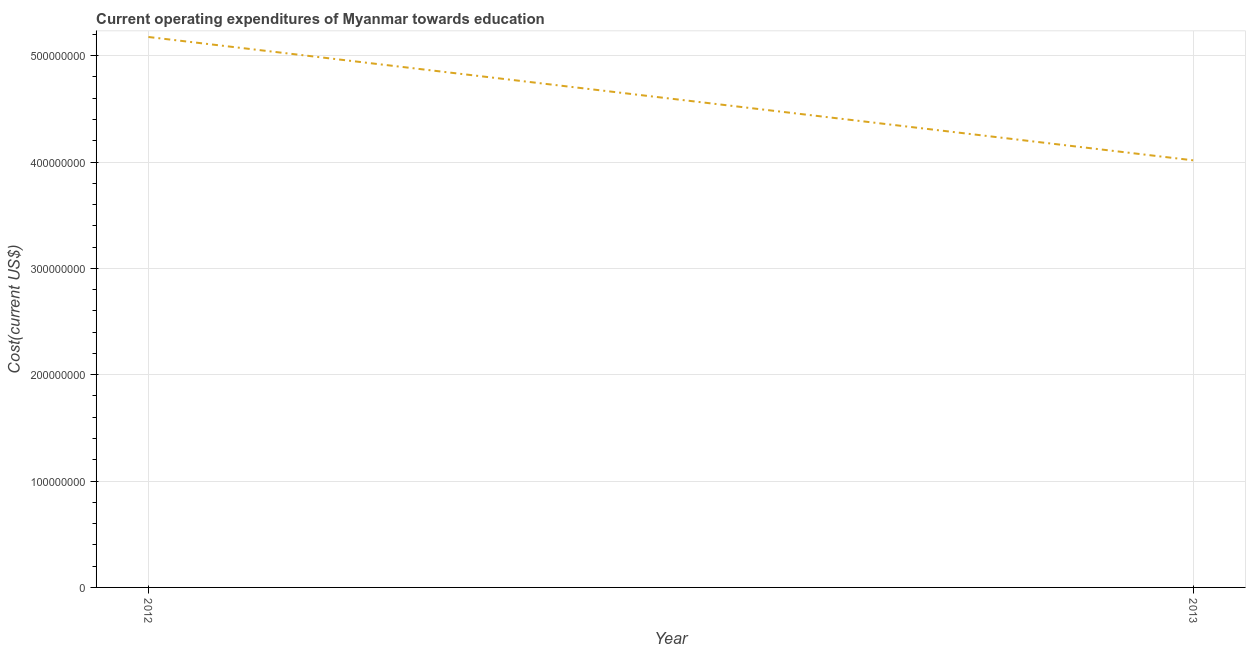What is the education expenditure in 2013?
Your response must be concise. 4.02e+08. Across all years, what is the maximum education expenditure?
Provide a succinct answer. 5.18e+08. Across all years, what is the minimum education expenditure?
Ensure brevity in your answer.  4.02e+08. What is the sum of the education expenditure?
Your answer should be very brief. 9.19e+08. What is the difference between the education expenditure in 2012 and 2013?
Make the answer very short. 1.16e+08. What is the average education expenditure per year?
Ensure brevity in your answer.  4.60e+08. What is the median education expenditure?
Your answer should be very brief. 4.60e+08. In how many years, is the education expenditure greater than 360000000 US$?
Ensure brevity in your answer.  2. What is the ratio of the education expenditure in 2012 to that in 2013?
Your answer should be compact. 1.29. In how many years, is the education expenditure greater than the average education expenditure taken over all years?
Ensure brevity in your answer.  1. How many years are there in the graph?
Your answer should be very brief. 2. What is the difference between two consecutive major ticks on the Y-axis?
Ensure brevity in your answer.  1.00e+08. Are the values on the major ticks of Y-axis written in scientific E-notation?
Your answer should be compact. No. Does the graph contain grids?
Your response must be concise. Yes. What is the title of the graph?
Your answer should be compact. Current operating expenditures of Myanmar towards education. What is the label or title of the Y-axis?
Your response must be concise. Cost(current US$). What is the Cost(current US$) in 2012?
Ensure brevity in your answer.  5.18e+08. What is the Cost(current US$) in 2013?
Your answer should be very brief. 4.02e+08. What is the difference between the Cost(current US$) in 2012 and 2013?
Provide a succinct answer. 1.16e+08. What is the ratio of the Cost(current US$) in 2012 to that in 2013?
Provide a short and direct response. 1.29. 